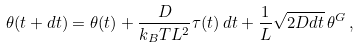<formula> <loc_0><loc_0><loc_500><loc_500>\theta ( t + d t ) = \theta ( t ) + \frac { D } { k _ { B } T L ^ { 2 } } \tau ( t ) \, d t + \frac { 1 } { L } \sqrt { 2 D d t } \, \theta ^ { G } \, ,</formula> 